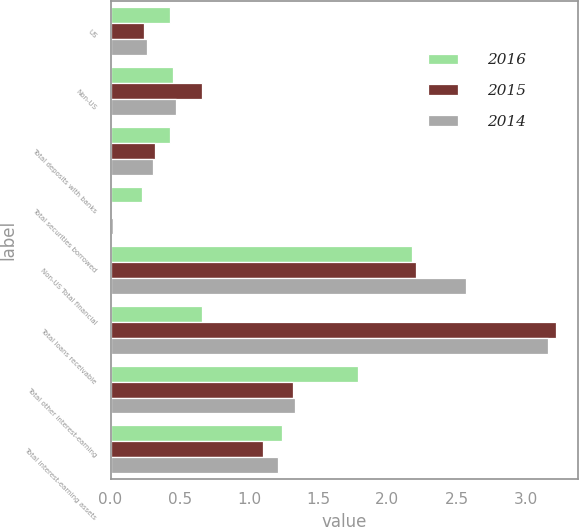<chart> <loc_0><loc_0><loc_500><loc_500><stacked_bar_chart><ecel><fcel>US<fcel>Non-US<fcel>Total deposits with banks<fcel>Total securities borrowed<fcel>Non-US Total financial<fcel>Total loans receivable<fcel>Total other interest-earning<fcel>Total interest-earning assets<nl><fcel>2016<fcel>0.43<fcel>0.45<fcel>0.43<fcel>0.23<fcel>2.18<fcel>0.66<fcel>1.79<fcel>1.24<nl><fcel>2015<fcel>0.24<fcel>0.66<fcel>0.32<fcel>0.01<fcel>2.21<fcel>3.22<fcel>1.32<fcel>1.1<nl><fcel>2014<fcel>0.26<fcel>0.47<fcel>0.31<fcel>0.02<fcel>2.57<fcel>3.16<fcel>1.33<fcel>1.21<nl></chart> 